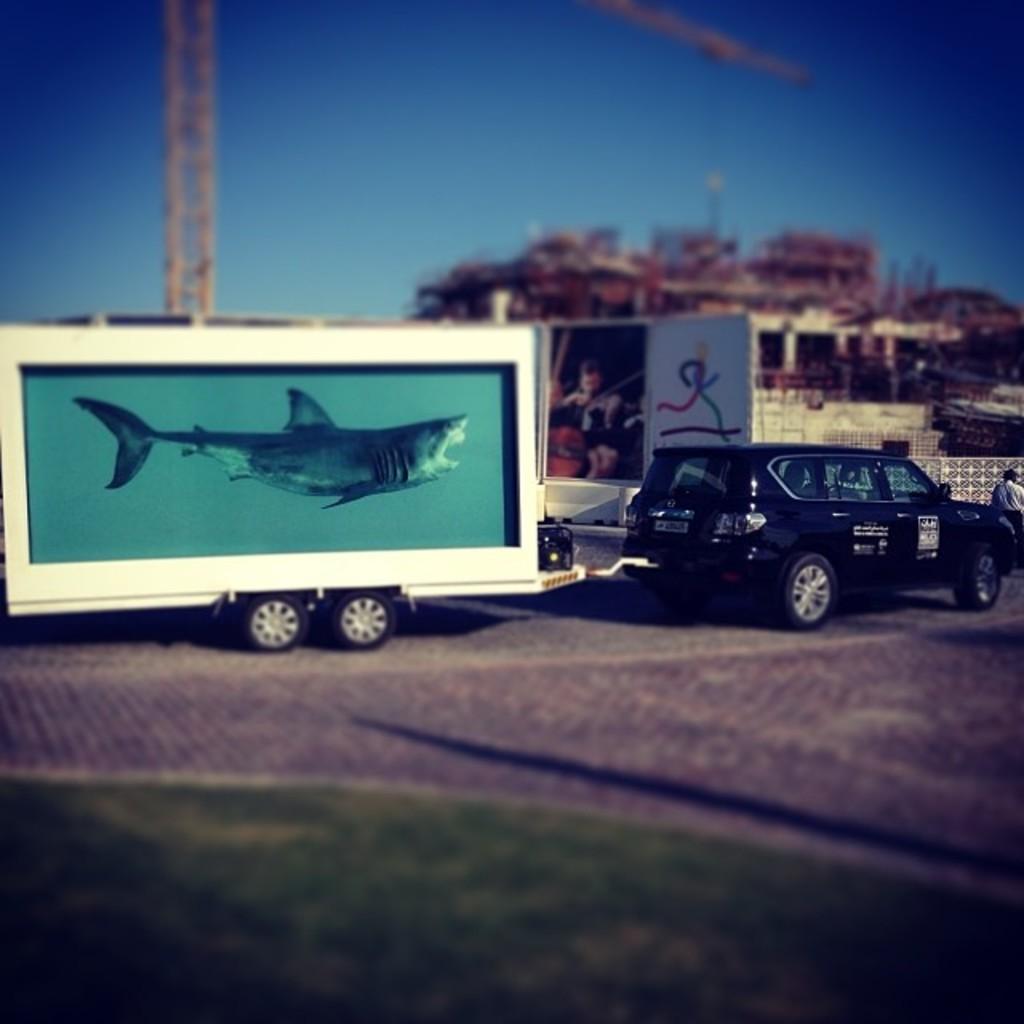Could you give a brief overview of what you see in this image? This is a car. I can see a truck, which is attached to a car. This looks like a hoarding. I can see a tower crane. This looks like a building. On the right side of the image, I can see a person standing. This is the grass. 